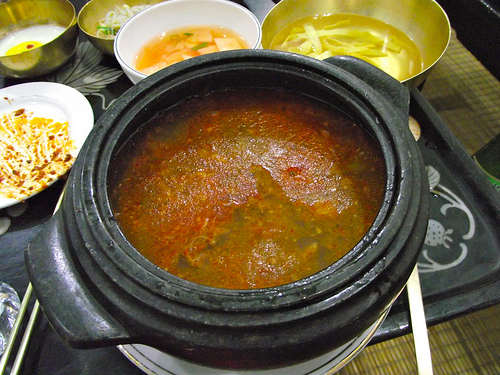<image>
Is the soup next to the bowl? Yes. The soup is positioned adjacent to the bowl, located nearby in the same general area. 